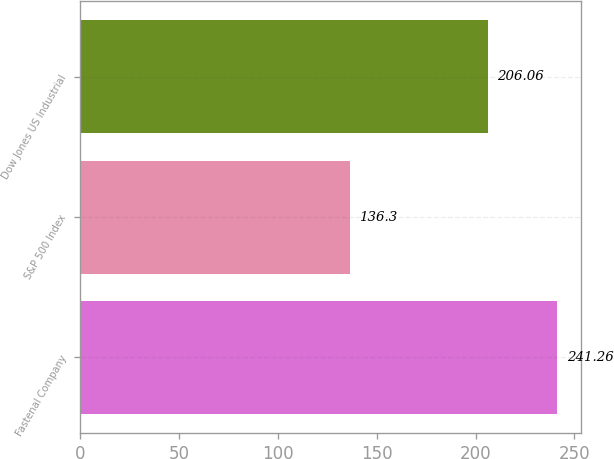<chart> <loc_0><loc_0><loc_500><loc_500><bar_chart><fcel>Fastenal Company<fcel>S&P 500 Index<fcel>Dow Jones US Industrial<nl><fcel>241.26<fcel>136.3<fcel>206.06<nl></chart> 